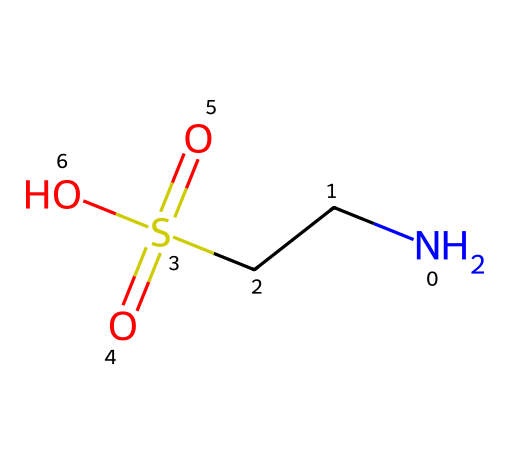What is the main functional group in this molecule? The molecule contains a sulfonic acid group, indicated by the presence of sulfur bonded to two oxygen atoms with one of those oxygens also bonded to a hydroxyl group (–OH). This identifies it as a sulfonic acid derivative.
Answer: sulfonic acid How many total oxygen atoms are present in the molecule? By analyzing the structure, we can see there are three oxygen atoms: two from the sulfonic acid part (–S(=O)(=O)–) and one from the hydroxyl group (–OH). Adding these gives a total of three.
Answer: three What is the oxidation state of sulfur in this chemical? The sulfur atom is bonded to two double-bonded oxygens and one hydroxyl oxygen. In this case, the oxidation state can be calculated as +6 (each double bond to oxygen counts as +2 and the single bond to oxygen in hydroxyl is +1, totaling +6 for sulfur).
Answer: six What type of reaction might this substance undergo due to the functional group? The sulfonic acid functional group makes this molecule a strong acid, indicating it would readily participate in protonation reactions.
Answer: protonation How many carbon atoms are in this molecule? By observing the structure, there is one carbon atom as indicated by the "NCC" part in the SMILES representation (the nitrogen and carbon sequence represents a carbon chain).
Answer: one What is the primary use of organosulfur compounds like this one in energy drinks? Organosulfur compounds can function as additives that enhance energy levels, often seen in the context of improving metabolism or promoting hydration in energy drinks.
Answer: additives 